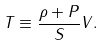<formula> <loc_0><loc_0><loc_500><loc_500>T \equiv \frac { \rho + P } { S } V .</formula> 